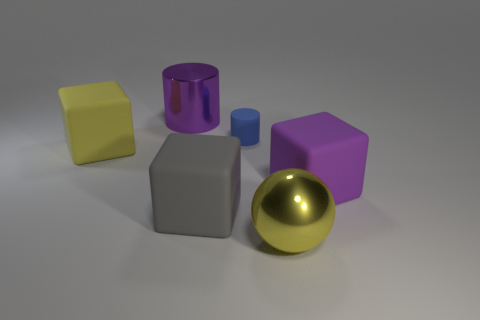Add 3 tiny cyan balls. How many objects exist? 9 Subtract all cylinders. How many objects are left? 4 Add 2 small blue objects. How many small blue objects exist? 3 Subtract 0 red balls. How many objects are left? 6 Subtract all big red rubber spheres. Subtract all small rubber objects. How many objects are left? 5 Add 4 gray rubber things. How many gray rubber things are left? 5 